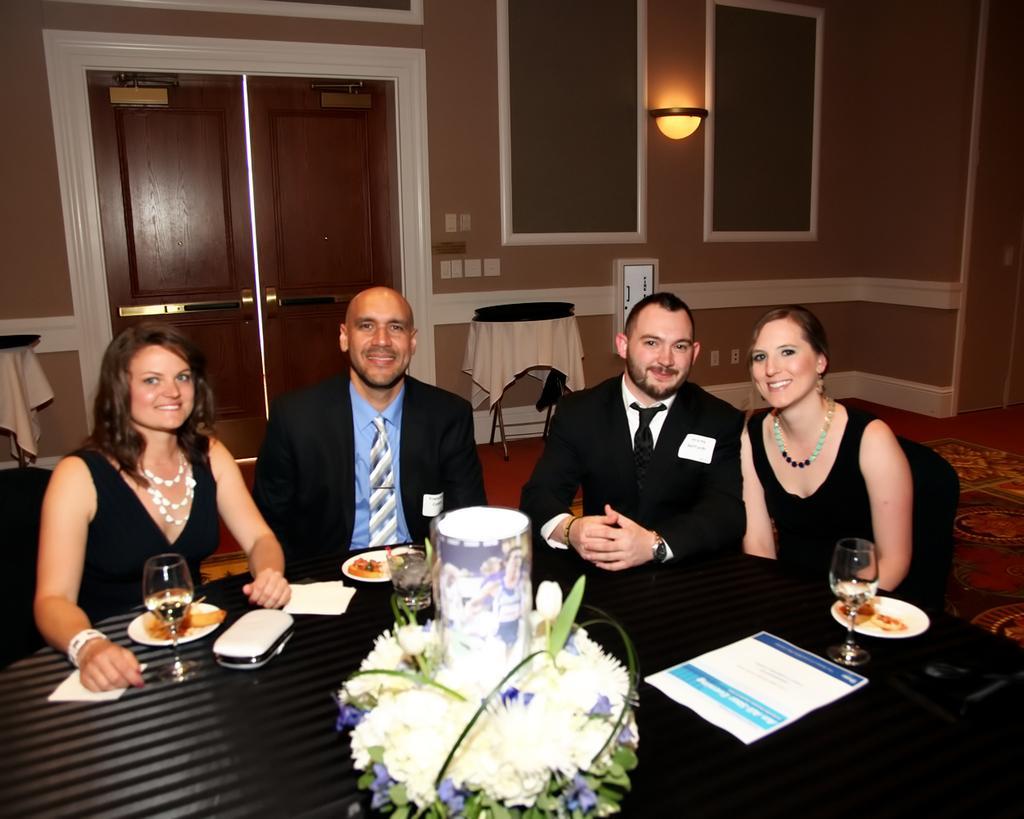Please provide a concise description of this image. On the background we can see wall, door and tables. Here we can see persons wearing black dress sitting on chairs infront of a table and they are carrying smile on their faces. On the table we can see plate of food, drinking glasses, flower vase ,papers, tissue paper and a wallet. This is a floor with carpet. 